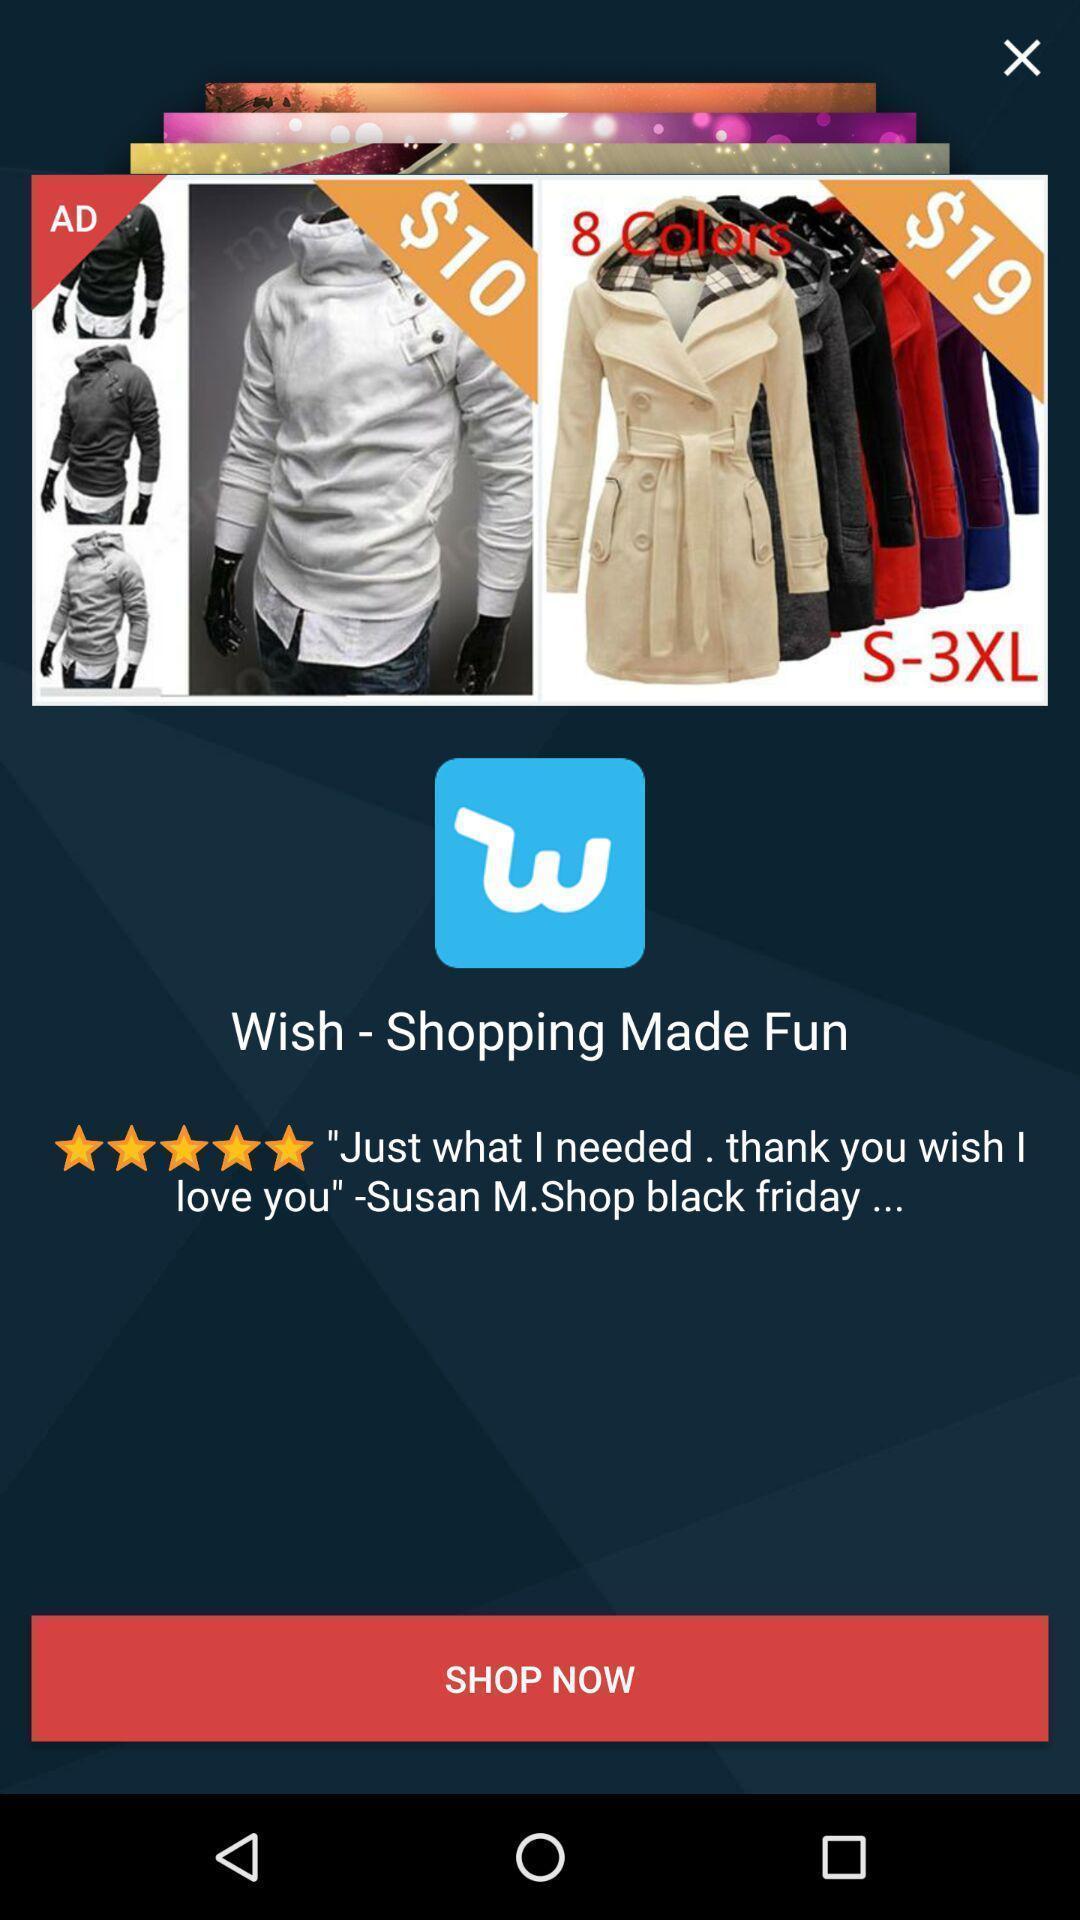Please provide a description for this image. Welcome page for the shopping app. 